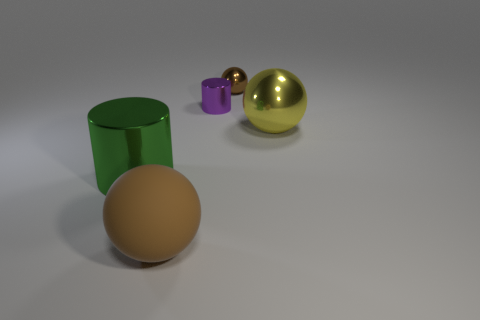How many other things are there of the same shape as the large yellow metallic object?
Your answer should be compact. 2. Is the large ball right of the matte sphere made of the same material as the large brown object?
Your answer should be very brief. No. What number of objects are small purple balls or brown spheres?
Give a very brief answer. 2. The purple thing that is the same shape as the large green object is what size?
Make the answer very short. Small. How big is the brown matte thing?
Make the answer very short. Large. Is the number of big green metallic things that are left of the large green metal thing greater than the number of green rubber balls?
Provide a succinct answer. No. Is there any other thing that has the same material as the purple cylinder?
Your response must be concise. Yes. Do the small shiny object on the right side of the purple cylinder and the big sphere that is in front of the green metallic cylinder have the same color?
Your answer should be compact. Yes. What is the material of the brown thing that is in front of the big thing that is behind the large object that is to the left of the brown matte object?
Make the answer very short. Rubber. Is the number of green things greater than the number of big cyan rubber cubes?
Ensure brevity in your answer.  Yes. 